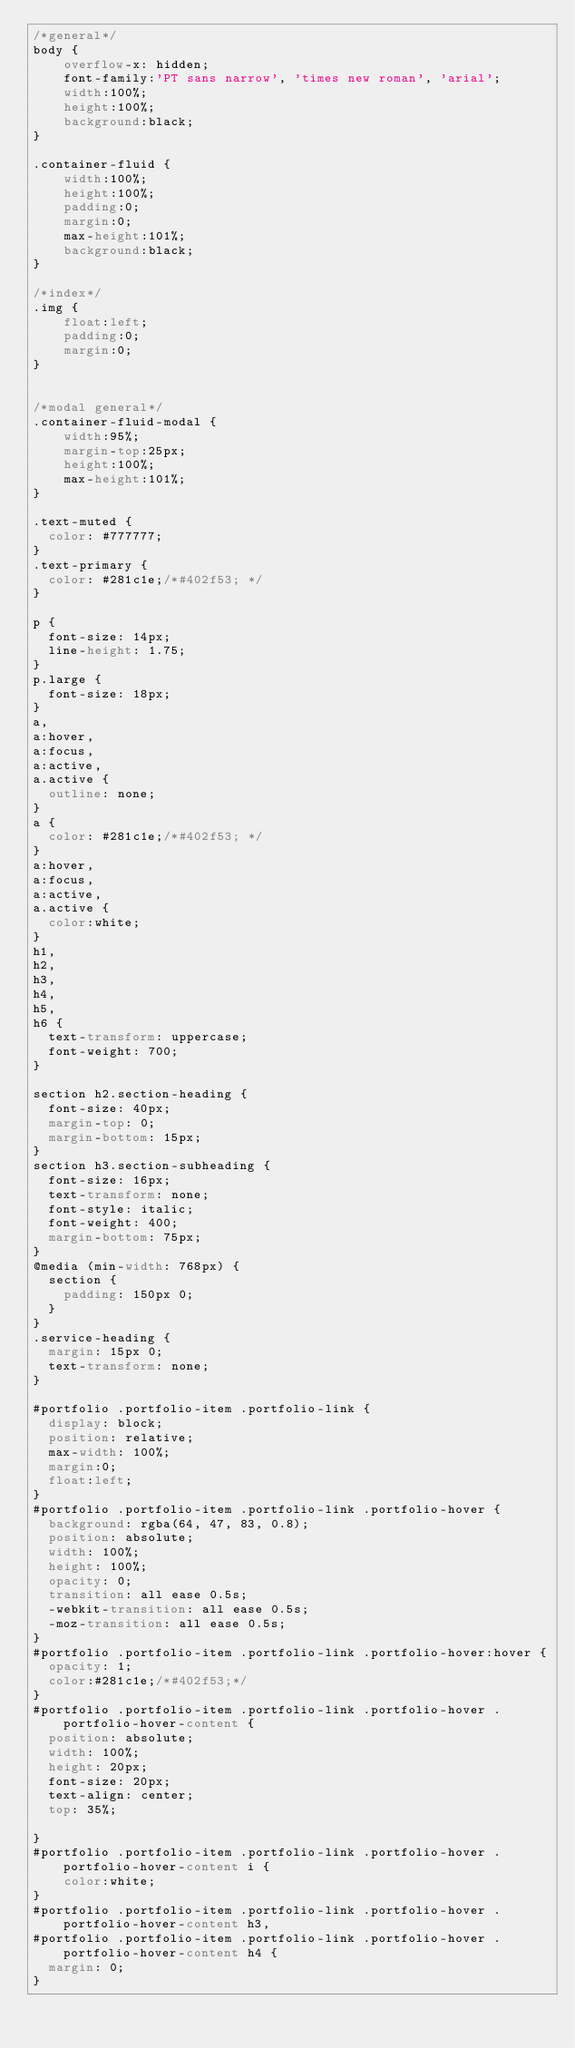Convert code to text. <code><loc_0><loc_0><loc_500><loc_500><_CSS_>/*general*/
body {
	overflow-x: hidden;
	font-family:'PT sans narrow', 'times new roman', 'arial';
	width:100%;
	height:100%;
	background:black;
}

.container-fluid {
	width:100%;
	height:100%;
	padding:0;
	margin:0; 
	max-height:101%;
	background:black;
}

/*index*/
.img {
	float:left;
	padding:0;
	margin:0;
}


/*modal general*/
.container-fluid-modal {
	width:95%;
	margin-top:25px;
	height:100%;
	max-height:101%;
}

.text-muted {
  color: #777777;
}
.text-primary {
  color: #281c1e;/*#402f53; */
}

p {
  font-size: 14px;
  line-height: 1.75;
}
p.large {
  font-size: 18px;
}
a,
a:hover,
a:focus,
a:active,
a.active {
  outline: none;
}
a {
  color: #281c1e;/*#402f53; */
}
a:hover,
a:focus,
a:active,
a.active {
  color:white;
}
h1,
h2,
h3,
h4,
h5,
h6 {
  text-transform: uppercase;
  font-weight: 700;
}

section h2.section-heading {
  font-size: 40px;
  margin-top: 0;
  margin-bottom: 15px;
}
section h3.section-subheading {
  font-size: 16px;
  text-transform: none;
  font-style: italic;
  font-weight: 400;
  margin-bottom: 75px;
}
@media (min-width: 768px) {
  section {
    padding: 150px 0;
  }
}
.service-heading {
  margin: 15px 0;
  text-transform: none;
}

#portfolio .portfolio-item .portfolio-link {
  display: block;
  position: relative;
  max-width: 100%;
  margin:0;
  float:left;
}
#portfolio .portfolio-item .portfolio-link .portfolio-hover {
  background: rgba(64, 47, 83, 0.8);
  position: absolute;
  width: 100%;
  height: 100%;
  opacity: 0;
  transition: all ease 0.5s;
  -webkit-transition: all ease 0.5s;
  -moz-transition: all ease 0.5s;
}
#portfolio .portfolio-item .portfolio-link .portfolio-hover:hover {
  opacity: 1;
  color:#281c1e;/*#402f53;*/
}
#portfolio .portfolio-item .portfolio-link .portfolio-hover .portfolio-hover-content {
  position: absolute;
  width: 100%;
  height: 20px;
  font-size: 20px;
  text-align: center;
  top: 35%;

}
#portfolio .portfolio-item .portfolio-link .portfolio-hover .portfolio-hover-content i {
	color:white;
}
#portfolio .portfolio-item .portfolio-link .portfolio-hover .portfolio-hover-content h3,
#portfolio .portfolio-item .portfolio-link .portfolio-hover .portfolio-hover-content h4 {
  margin: 0;
}</code> 